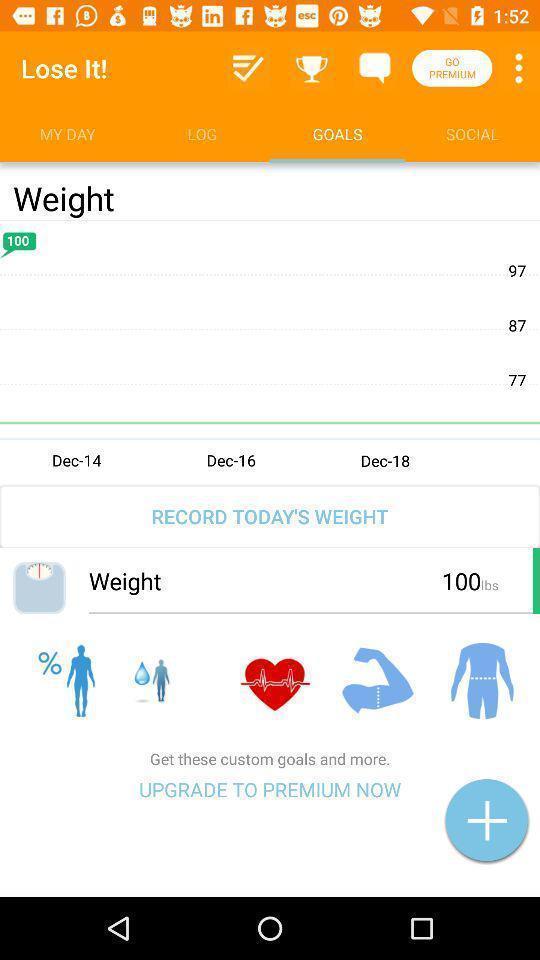Please provide a description for this image. Page shows range of weight lose in an health application. 